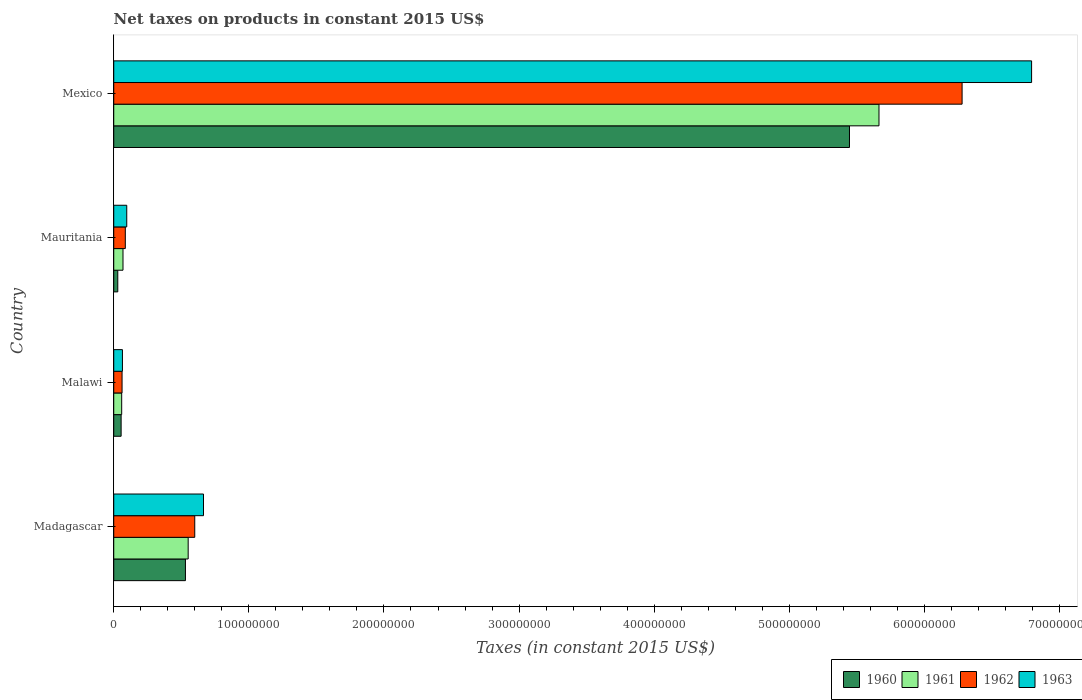How many different coloured bars are there?
Your answer should be very brief. 4. Are the number of bars per tick equal to the number of legend labels?
Offer a terse response. Yes. Are the number of bars on each tick of the Y-axis equal?
Provide a succinct answer. Yes. What is the label of the 2nd group of bars from the top?
Ensure brevity in your answer.  Mauritania. What is the net taxes on products in 1962 in Malawi?
Your answer should be very brief. 6.16e+06. Across all countries, what is the maximum net taxes on products in 1962?
Ensure brevity in your answer.  6.28e+08. Across all countries, what is the minimum net taxes on products in 1962?
Provide a succinct answer. 6.16e+06. In which country was the net taxes on products in 1962 maximum?
Your answer should be compact. Mexico. In which country was the net taxes on products in 1961 minimum?
Keep it short and to the point. Malawi. What is the total net taxes on products in 1963 in the graph?
Make the answer very short. 7.62e+08. What is the difference between the net taxes on products in 1962 in Madagascar and that in Mexico?
Provide a short and direct response. -5.68e+08. What is the difference between the net taxes on products in 1963 in Mexico and the net taxes on products in 1960 in Madagascar?
Your answer should be very brief. 6.26e+08. What is the average net taxes on products in 1962 per country?
Offer a terse response. 1.76e+08. What is the difference between the net taxes on products in 1962 and net taxes on products in 1961 in Mauritania?
Your response must be concise. 1.71e+06. What is the ratio of the net taxes on products in 1961 in Mauritania to that in Mexico?
Your answer should be very brief. 0.01. Is the difference between the net taxes on products in 1962 in Mauritania and Mexico greater than the difference between the net taxes on products in 1961 in Mauritania and Mexico?
Keep it short and to the point. No. What is the difference between the highest and the second highest net taxes on products in 1961?
Make the answer very short. 5.11e+08. What is the difference between the highest and the lowest net taxes on products in 1961?
Ensure brevity in your answer.  5.61e+08. What does the 1st bar from the bottom in Malawi represents?
Your response must be concise. 1960. Does the graph contain any zero values?
Your answer should be compact. No. Does the graph contain grids?
Keep it short and to the point. No. Where does the legend appear in the graph?
Ensure brevity in your answer.  Bottom right. How many legend labels are there?
Make the answer very short. 4. How are the legend labels stacked?
Your answer should be very brief. Horizontal. What is the title of the graph?
Your answer should be very brief. Net taxes on products in constant 2015 US$. What is the label or title of the X-axis?
Ensure brevity in your answer.  Taxes (in constant 2015 US$). What is the Taxes (in constant 2015 US$) of 1960 in Madagascar?
Your answer should be very brief. 5.31e+07. What is the Taxes (in constant 2015 US$) of 1961 in Madagascar?
Provide a succinct answer. 5.51e+07. What is the Taxes (in constant 2015 US$) in 1962 in Madagascar?
Offer a very short reply. 6.00e+07. What is the Taxes (in constant 2015 US$) in 1963 in Madagascar?
Offer a very short reply. 6.64e+07. What is the Taxes (in constant 2015 US$) of 1960 in Malawi?
Offer a terse response. 5.46e+06. What is the Taxes (in constant 2015 US$) of 1961 in Malawi?
Offer a very short reply. 5.88e+06. What is the Taxes (in constant 2015 US$) of 1962 in Malawi?
Make the answer very short. 6.16e+06. What is the Taxes (in constant 2015 US$) of 1963 in Malawi?
Provide a succinct answer. 6.44e+06. What is the Taxes (in constant 2015 US$) in 1960 in Mauritania?
Offer a terse response. 3.00e+06. What is the Taxes (in constant 2015 US$) in 1961 in Mauritania?
Provide a succinct answer. 6.85e+06. What is the Taxes (in constant 2015 US$) in 1962 in Mauritania?
Your response must be concise. 8.56e+06. What is the Taxes (in constant 2015 US$) in 1963 in Mauritania?
Provide a short and direct response. 9.63e+06. What is the Taxes (in constant 2015 US$) in 1960 in Mexico?
Your answer should be very brief. 5.45e+08. What is the Taxes (in constant 2015 US$) in 1961 in Mexico?
Make the answer very short. 5.66e+08. What is the Taxes (in constant 2015 US$) of 1962 in Mexico?
Make the answer very short. 6.28e+08. What is the Taxes (in constant 2015 US$) in 1963 in Mexico?
Make the answer very short. 6.79e+08. Across all countries, what is the maximum Taxes (in constant 2015 US$) in 1960?
Your answer should be compact. 5.45e+08. Across all countries, what is the maximum Taxes (in constant 2015 US$) of 1961?
Make the answer very short. 5.66e+08. Across all countries, what is the maximum Taxes (in constant 2015 US$) in 1962?
Your response must be concise. 6.28e+08. Across all countries, what is the maximum Taxes (in constant 2015 US$) in 1963?
Give a very brief answer. 6.79e+08. Across all countries, what is the minimum Taxes (in constant 2015 US$) of 1960?
Your answer should be very brief. 3.00e+06. Across all countries, what is the minimum Taxes (in constant 2015 US$) in 1961?
Provide a succinct answer. 5.88e+06. Across all countries, what is the minimum Taxes (in constant 2015 US$) in 1962?
Provide a short and direct response. 6.16e+06. Across all countries, what is the minimum Taxes (in constant 2015 US$) of 1963?
Offer a very short reply. 6.44e+06. What is the total Taxes (in constant 2015 US$) in 1960 in the graph?
Provide a short and direct response. 6.06e+08. What is the total Taxes (in constant 2015 US$) of 1961 in the graph?
Give a very brief answer. 6.34e+08. What is the total Taxes (in constant 2015 US$) in 1962 in the graph?
Ensure brevity in your answer.  7.03e+08. What is the total Taxes (in constant 2015 US$) in 1963 in the graph?
Keep it short and to the point. 7.62e+08. What is the difference between the Taxes (in constant 2015 US$) in 1960 in Madagascar and that in Malawi?
Offer a very short reply. 4.76e+07. What is the difference between the Taxes (in constant 2015 US$) of 1961 in Madagascar and that in Malawi?
Provide a short and direct response. 4.92e+07. What is the difference between the Taxes (in constant 2015 US$) in 1962 in Madagascar and that in Malawi?
Your answer should be very brief. 5.38e+07. What is the difference between the Taxes (in constant 2015 US$) in 1963 in Madagascar and that in Malawi?
Ensure brevity in your answer.  6.00e+07. What is the difference between the Taxes (in constant 2015 US$) in 1960 in Madagascar and that in Mauritania?
Provide a succinct answer. 5.01e+07. What is the difference between the Taxes (in constant 2015 US$) in 1961 in Madagascar and that in Mauritania?
Make the answer very short. 4.82e+07. What is the difference between the Taxes (in constant 2015 US$) in 1962 in Madagascar and that in Mauritania?
Your answer should be very brief. 5.14e+07. What is the difference between the Taxes (in constant 2015 US$) in 1963 in Madagascar and that in Mauritania?
Provide a succinct answer. 5.68e+07. What is the difference between the Taxes (in constant 2015 US$) of 1960 in Madagascar and that in Mexico?
Make the answer very short. -4.91e+08. What is the difference between the Taxes (in constant 2015 US$) in 1961 in Madagascar and that in Mexico?
Your response must be concise. -5.11e+08. What is the difference between the Taxes (in constant 2015 US$) in 1962 in Madagascar and that in Mexico?
Ensure brevity in your answer.  -5.68e+08. What is the difference between the Taxes (in constant 2015 US$) of 1963 in Madagascar and that in Mexico?
Your answer should be very brief. -6.13e+08. What is the difference between the Taxes (in constant 2015 US$) in 1960 in Malawi and that in Mauritania?
Provide a short and direct response. 2.46e+06. What is the difference between the Taxes (in constant 2015 US$) in 1961 in Malawi and that in Mauritania?
Give a very brief answer. -9.67e+05. What is the difference between the Taxes (in constant 2015 US$) of 1962 in Malawi and that in Mauritania?
Offer a very short reply. -2.40e+06. What is the difference between the Taxes (in constant 2015 US$) in 1963 in Malawi and that in Mauritania?
Offer a terse response. -3.19e+06. What is the difference between the Taxes (in constant 2015 US$) of 1960 in Malawi and that in Mexico?
Ensure brevity in your answer.  -5.39e+08. What is the difference between the Taxes (in constant 2015 US$) of 1961 in Malawi and that in Mexico?
Make the answer very short. -5.61e+08. What is the difference between the Taxes (in constant 2015 US$) in 1962 in Malawi and that in Mexico?
Give a very brief answer. -6.22e+08. What is the difference between the Taxes (in constant 2015 US$) in 1963 in Malawi and that in Mexico?
Provide a short and direct response. -6.73e+08. What is the difference between the Taxes (in constant 2015 US$) of 1960 in Mauritania and that in Mexico?
Offer a terse response. -5.42e+08. What is the difference between the Taxes (in constant 2015 US$) of 1961 in Mauritania and that in Mexico?
Keep it short and to the point. -5.60e+08. What is the difference between the Taxes (in constant 2015 US$) in 1962 in Mauritania and that in Mexico?
Provide a short and direct response. -6.19e+08. What is the difference between the Taxes (in constant 2015 US$) in 1963 in Mauritania and that in Mexico?
Offer a very short reply. -6.70e+08. What is the difference between the Taxes (in constant 2015 US$) in 1960 in Madagascar and the Taxes (in constant 2015 US$) in 1961 in Malawi?
Your answer should be compact. 4.72e+07. What is the difference between the Taxes (in constant 2015 US$) of 1960 in Madagascar and the Taxes (in constant 2015 US$) of 1962 in Malawi?
Offer a terse response. 4.69e+07. What is the difference between the Taxes (in constant 2015 US$) of 1960 in Madagascar and the Taxes (in constant 2015 US$) of 1963 in Malawi?
Your response must be concise. 4.66e+07. What is the difference between the Taxes (in constant 2015 US$) of 1961 in Madagascar and the Taxes (in constant 2015 US$) of 1962 in Malawi?
Your answer should be compact. 4.89e+07. What is the difference between the Taxes (in constant 2015 US$) in 1961 in Madagascar and the Taxes (in constant 2015 US$) in 1963 in Malawi?
Keep it short and to the point. 4.87e+07. What is the difference between the Taxes (in constant 2015 US$) in 1962 in Madagascar and the Taxes (in constant 2015 US$) in 1963 in Malawi?
Give a very brief answer. 5.35e+07. What is the difference between the Taxes (in constant 2015 US$) of 1960 in Madagascar and the Taxes (in constant 2015 US$) of 1961 in Mauritania?
Ensure brevity in your answer.  4.62e+07. What is the difference between the Taxes (in constant 2015 US$) of 1960 in Madagascar and the Taxes (in constant 2015 US$) of 1962 in Mauritania?
Make the answer very short. 4.45e+07. What is the difference between the Taxes (in constant 2015 US$) in 1960 in Madagascar and the Taxes (in constant 2015 US$) in 1963 in Mauritania?
Keep it short and to the point. 4.34e+07. What is the difference between the Taxes (in constant 2015 US$) in 1961 in Madagascar and the Taxes (in constant 2015 US$) in 1962 in Mauritania?
Your answer should be compact. 4.65e+07. What is the difference between the Taxes (in constant 2015 US$) in 1961 in Madagascar and the Taxes (in constant 2015 US$) in 1963 in Mauritania?
Offer a terse response. 4.55e+07. What is the difference between the Taxes (in constant 2015 US$) of 1962 in Madagascar and the Taxes (in constant 2015 US$) of 1963 in Mauritania?
Your answer should be compact. 5.03e+07. What is the difference between the Taxes (in constant 2015 US$) of 1960 in Madagascar and the Taxes (in constant 2015 US$) of 1961 in Mexico?
Offer a very short reply. -5.13e+08. What is the difference between the Taxes (in constant 2015 US$) of 1960 in Madagascar and the Taxes (in constant 2015 US$) of 1962 in Mexico?
Your response must be concise. -5.75e+08. What is the difference between the Taxes (in constant 2015 US$) of 1960 in Madagascar and the Taxes (in constant 2015 US$) of 1963 in Mexico?
Provide a succinct answer. -6.26e+08. What is the difference between the Taxes (in constant 2015 US$) in 1961 in Madagascar and the Taxes (in constant 2015 US$) in 1962 in Mexico?
Provide a short and direct response. -5.73e+08. What is the difference between the Taxes (in constant 2015 US$) in 1961 in Madagascar and the Taxes (in constant 2015 US$) in 1963 in Mexico?
Make the answer very short. -6.24e+08. What is the difference between the Taxes (in constant 2015 US$) of 1962 in Madagascar and the Taxes (in constant 2015 US$) of 1963 in Mexico?
Your response must be concise. -6.19e+08. What is the difference between the Taxes (in constant 2015 US$) in 1960 in Malawi and the Taxes (in constant 2015 US$) in 1961 in Mauritania?
Your answer should be compact. -1.39e+06. What is the difference between the Taxes (in constant 2015 US$) in 1960 in Malawi and the Taxes (in constant 2015 US$) in 1962 in Mauritania?
Your response must be concise. -3.10e+06. What is the difference between the Taxes (in constant 2015 US$) in 1960 in Malawi and the Taxes (in constant 2015 US$) in 1963 in Mauritania?
Provide a succinct answer. -4.17e+06. What is the difference between the Taxes (in constant 2015 US$) of 1961 in Malawi and the Taxes (in constant 2015 US$) of 1962 in Mauritania?
Ensure brevity in your answer.  -2.68e+06. What is the difference between the Taxes (in constant 2015 US$) of 1961 in Malawi and the Taxes (in constant 2015 US$) of 1963 in Mauritania?
Your answer should be compact. -3.75e+06. What is the difference between the Taxes (in constant 2015 US$) in 1962 in Malawi and the Taxes (in constant 2015 US$) in 1963 in Mauritania?
Your answer should be very brief. -3.47e+06. What is the difference between the Taxes (in constant 2015 US$) of 1960 in Malawi and the Taxes (in constant 2015 US$) of 1961 in Mexico?
Offer a terse response. -5.61e+08. What is the difference between the Taxes (in constant 2015 US$) in 1960 in Malawi and the Taxes (in constant 2015 US$) in 1962 in Mexico?
Provide a short and direct response. -6.22e+08. What is the difference between the Taxes (in constant 2015 US$) in 1960 in Malawi and the Taxes (in constant 2015 US$) in 1963 in Mexico?
Your answer should be compact. -6.74e+08. What is the difference between the Taxes (in constant 2015 US$) of 1961 in Malawi and the Taxes (in constant 2015 US$) of 1962 in Mexico?
Ensure brevity in your answer.  -6.22e+08. What is the difference between the Taxes (in constant 2015 US$) in 1961 in Malawi and the Taxes (in constant 2015 US$) in 1963 in Mexico?
Provide a succinct answer. -6.73e+08. What is the difference between the Taxes (in constant 2015 US$) in 1962 in Malawi and the Taxes (in constant 2015 US$) in 1963 in Mexico?
Provide a succinct answer. -6.73e+08. What is the difference between the Taxes (in constant 2015 US$) of 1960 in Mauritania and the Taxes (in constant 2015 US$) of 1961 in Mexico?
Make the answer very short. -5.63e+08. What is the difference between the Taxes (in constant 2015 US$) of 1960 in Mauritania and the Taxes (in constant 2015 US$) of 1962 in Mexico?
Your answer should be very brief. -6.25e+08. What is the difference between the Taxes (in constant 2015 US$) in 1960 in Mauritania and the Taxes (in constant 2015 US$) in 1963 in Mexico?
Make the answer very short. -6.76e+08. What is the difference between the Taxes (in constant 2015 US$) of 1961 in Mauritania and the Taxes (in constant 2015 US$) of 1962 in Mexico?
Give a very brief answer. -6.21e+08. What is the difference between the Taxes (in constant 2015 US$) in 1961 in Mauritania and the Taxes (in constant 2015 US$) in 1963 in Mexico?
Provide a short and direct response. -6.73e+08. What is the difference between the Taxes (in constant 2015 US$) of 1962 in Mauritania and the Taxes (in constant 2015 US$) of 1963 in Mexico?
Offer a terse response. -6.71e+08. What is the average Taxes (in constant 2015 US$) of 1960 per country?
Your response must be concise. 1.52e+08. What is the average Taxes (in constant 2015 US$) of 1961 per country?
Provide a succinct answer. 1.59e+08. What is the average Taxes (in constant 2015 US$) in 1962 per country?
Offer a very short reply. 1.76e+08. What is the average Taxes (in constant 2015 US$) of 1963 per country?
Your answer should be compact. 1.90e+08. What is the difference between the Taxes (in constant 2015 US$) of 1960 and Taxes (in constant 2015 US$) of 1961 in Madagascar?
Provide a succinct answer. -2.03e+06. What is the difference between the Taxes (in constant 2015 US$) in 1960 and Taxes (in constant 2015 US$) in 1962 in Madagascar?
Your answer should be compact. -6.89e+06. What is the difference between the Taxes (in constant 2015 US$) of 1960 and Taxes (in constant 2015 US$) of 1963 in Madagascar?
Offer a very short reply. -1.34e+07. What is the difference between the Taxes (in constant 2015 US$) of 1961 and Taxes (in constant 2015 US$) of 1962 in Madagascar?
Your response must be concise. -4.86e+06. What is the difference between the Taxes (in constant 2015 US$) of 1961 and Taxes (in constant 2015 US$) of 1963 in Madagascar?
Ensure brevity in your answer.  -1.13e+07. What is the difference between the Taxes (in constant 2015 US$) in 1962 and Taxes (in constant 2015 US$) in 1963 in Madagascar?
Give a very brief answer. -6.48e+06. What is the difference between the Taxes (in constant 2015 US$) in 1960 and Taxes (in constant 2015 US$) in 1961 in Malawi?
Give a very brief answer. -4.20e+05. What is the difference between the Taxes (in constant 2015 US$) of 1960 and Taxes (in constant 2015 US$) of 1962 in Malawi?
Provide a succinct answer. -7.00e+05. What is the difference between the Taxes (in constant 2015 US$) of 1960 and Taxes (in constant 2015 US$) of 1963 in Malawi?
Your response must be concise. -9.80e+05. What is the difference between the Taxes (in constant 2015 US$) of 1961 and Taxes (in constant 2015 US$) of 1962 in Malawi?
Provide a succinct answer. -2.80e+05. What is the difference between the Taxes (in constant 2015 US$) in 1961 and Taxes (in constant 2015 US$) in 1963 in Malawi?
Offer a terse response. -5.60e+05. What is the difference between the Taxes (in constant 2015 US$) of 1962 and Taxes (in constant 2015 US$) of 1963 in Malawi?
Your answer should be compact. -2.80e+05. What is the difference between the Taxes (in constant 2015 US$) in 1960 and Taxes (in constant 2015 US$) in 1961 in Mauritania?
Keep it short and to the point. -3.85e+06. What is the difference between the Taxes (in constant 2015 US$) in 1960 and Taxes (in constant 2015 US$) in 1962 in Mauritania?
Ensure brevity in your answer.  -5.56e+06. What is the difference between the Taxes (in constant 2015 US$) in 1960 and Taxes (in constant 2015 US$) in 1963 in Mauritania?
Your answer should be very brief. -6.63e+06. What is the difference between the Taxes (in constant 2015 US$) of 1961 and Taxes (in constant 2015 US$) of 1962 in Mauritania?
Make the answer very short. -1.71e+06. What is the difference between the Taxes (in constant 2015 US$) of 1961 and Taxes (in constant 2015 US$) of 1963 in Mauritania?
Offer a very short reply. -2.78e+06. What is the difference between the Taxes (in constant 2015 US$) of 1962 and Taxes (in constant 2015 US$) of 1963 in Mauritania?
Offer a terse response. -1.07e+06. What is the difference between the Taxes (in constant 2015 US$) in 1960 and Taxes (in constant 2015 US$) in 1961 in Mexico?
Provide a succinct answer. -2.18e+07. What is the difference between the Taxes (in constant 2015 US$) of 1960 and Taxes (in constant 2015 US$) of 1962 in Mexico?
Keep it short and to the point. -8.34e+07. What is the difference between the Taxes (in constant 2015 US$) of 1960 and Taxes (in constant 2015 US$) of 1963 in Mexico?
Keep it short and to the point. -1.35e+08. What is the difference between the Taxes (in constant 2015 US$) of 1961 and Taxes (in constant 2015 US$) of 1962 in Mexico?
Provide a succinct answer. -6.15e+07. What is the difference between the Taxes (in constant 2015 US$) in 1961 and Taxes (in constant 2015 US$) in 1963 in Mexico?
Your answer should be very brief. -1.13e+08. What is the difference between the Taxes (in constant 2015 US$) in 1962 and Taxes (in constant 2015 US$) in 1963 in Mexico?
Keep it short and to the point. -5.14e+07. What is the ratio of the Taxes (in constant 2015 US$) in 1960 in Madagascar to that in Malawi?
Your response must be concise. 9.72. What is the ratio of the Taxes (in constant 2015 US$) of 1961 in Madagascar to that in Malawi?
Offer a very short reply. 9.37. What is the ratio of the Taxes (in constant 2015 US$) of 1962 in Madagascar to that in Malawi?
Provide a succinct answer. 9.73. What is the ratio of the Taxes (in constant 2015 US$) of 1963 in Madagascar to that in Malawi?
Your answer should be very brief. 10.32. What is the ratio of the Taxes (in constant 2015 US$) of 1960 in Madagascar to that in Mauritania?
Offer a very short reply. 17.72. What is the ratio of the Taxes (in constant 2015 US$) in 1961 in Madagascar to that in Mauritania?
Offer a very short reply. 8.05. What is the ratio of the Taxes (in constant 2015 US$) of 1962 in Madagascar to that in Mauritania?
Ensure brevity in your answer.  7. What is the ratio of the Taxes (in constant 2015 US$) of 1963 in Madagascar to that in Mauritania?
Offer a very short reply. 6.9. What is the ratio of the Taxes (in constant 2015 US$) of 1960 in Madagascar to that in Mexico?
Make the answer very short. 0.1. What is the ratio of the Taxes (in constant 2015 US$) in 1961 in Madagascar to that in Mexico?
Provide a succinct answer. 0.1. What is the ratio of the Taxes (in constant 2015 US$) of 1962 in Madagascar to that in Mexico?
Give a very brief answer. 0.1. What is the ratio of the Taxes (in constant 2015 US$) in 1963 in Madagascar to that in Mexico?
Keep it short and to the point. 0.1. What is the ratio of the Taxes (in constant 2015 US$) of 1960 in Malawi to that in Mauritania?
Offer a very short reply. 1.82. What is the ratio of the Taxes (in constant 2015 US$) of 1961 in Malawi to that in Mauritania?
Give a very brief answer. 0.86. What is the ratio of the Taxes (in constant 2015 US$) in 1962 in Malawi to that in Mauritania?
Provide a short and direct response. 0.72. What is the ratio of the Taxes (in constant 2015 US$) of 1963 in Malawi to that in Mauritania?
Make the answer very short. 0.67. What is the ratio of the Taxes (in constant 2015 US$) in 1961 in Malawi to that in Mexico?
Provide a succinct answer. 0.01. What is the ratio of the Taxes (in constant 2015 US$) of 1962 in Malawi to that in Mexico?
Provide a succinct answer. 0.01. What is the ratio of the Taxes (in constant 2015 US$) in 1963 in Malawi to that in Mexico?
Keep it short and to the point. 0.01. What is the ratio of the Taxes (in constant 2015 US$) of 1960 in Mauritania to that in Mexico?
Offer a very short reply. 0.01. What is the ratio of the Taxes (in constant 2015 US$) of 1961 in Mauritania to that in Mexico?
Ensure brevity in your answer.  0.01. What is the ratio of the Taxes (in constant 2015 US$) of 1962 in Mauritania to that in Mexico?
Provide a short and direct response. 0.01. What is the ratio of the Taxes (in constant 2015 US$) of 1963 in Mauritania to that in Mexico?
Make the answer very short. 0.01. What is the difference between the highest and the second highest Taxes (in constant 2015 US$) in 1960?
Provide a short and direct response. 4.91e+08. What is the difference between the highest and the second highest Taxes (in constant 2015 US$) of 1961?
Offer a very short reply. 5.11e+08. What is the difference between the highest and the second highest Taxes (in constant 2015 US$) in 1962?
Keep it short and to the point. 5.68e+08. What is the difference between the highest and the second highest Taxes (in constant 2015 US$) in 1963?
Offer a terse response. 6.13e+08. What is the difference between the highest and the lowest Taxes (in constant 2015 US$) of 1960?
Provide a succinct answer. 5.42e+08. What is the difference between the highest and the lowest Taxes (in constant 2015 US$) of 1961?
Keep it short and to the point. 5.61e+08. What is the difference between the highest and the lowest Taxes (in constant 2015 US$) in 1962?
Ensure brevity in your answer.  6.22e+08. What is the difference between the highest and the lowest Taxes (in constant 2015 US$) of 1963?
Provide a succinct answer. 6.73e+08. 